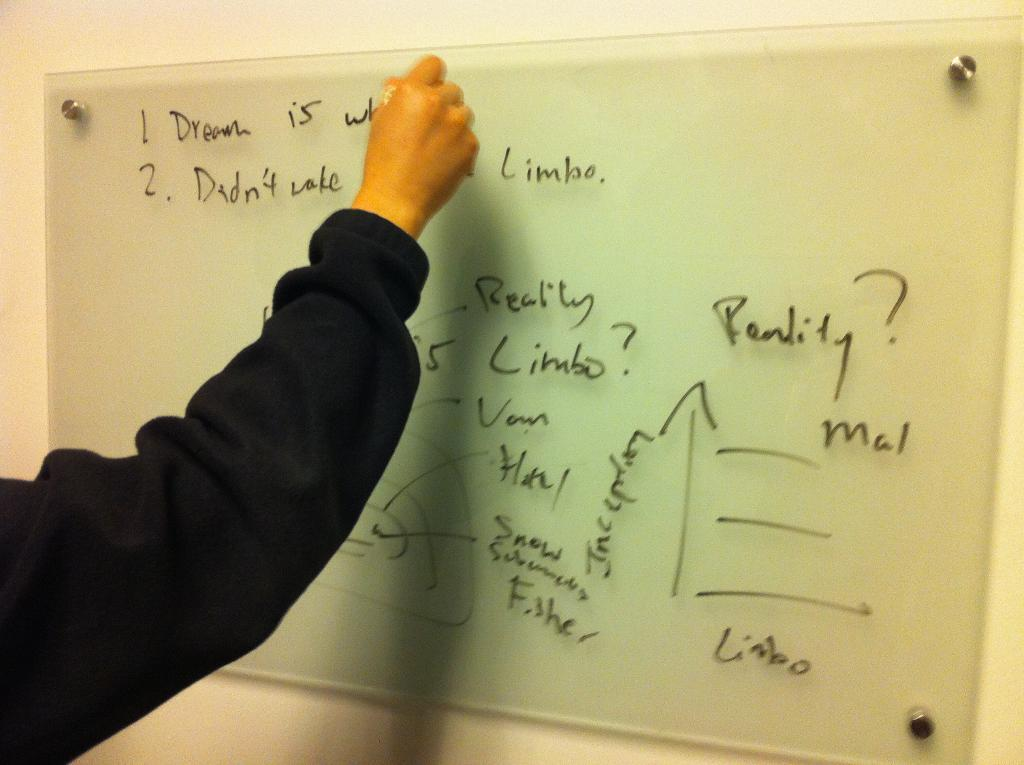<image>
Describe the image concisely. Person writing on a white board that starts off with the word "Dream". 